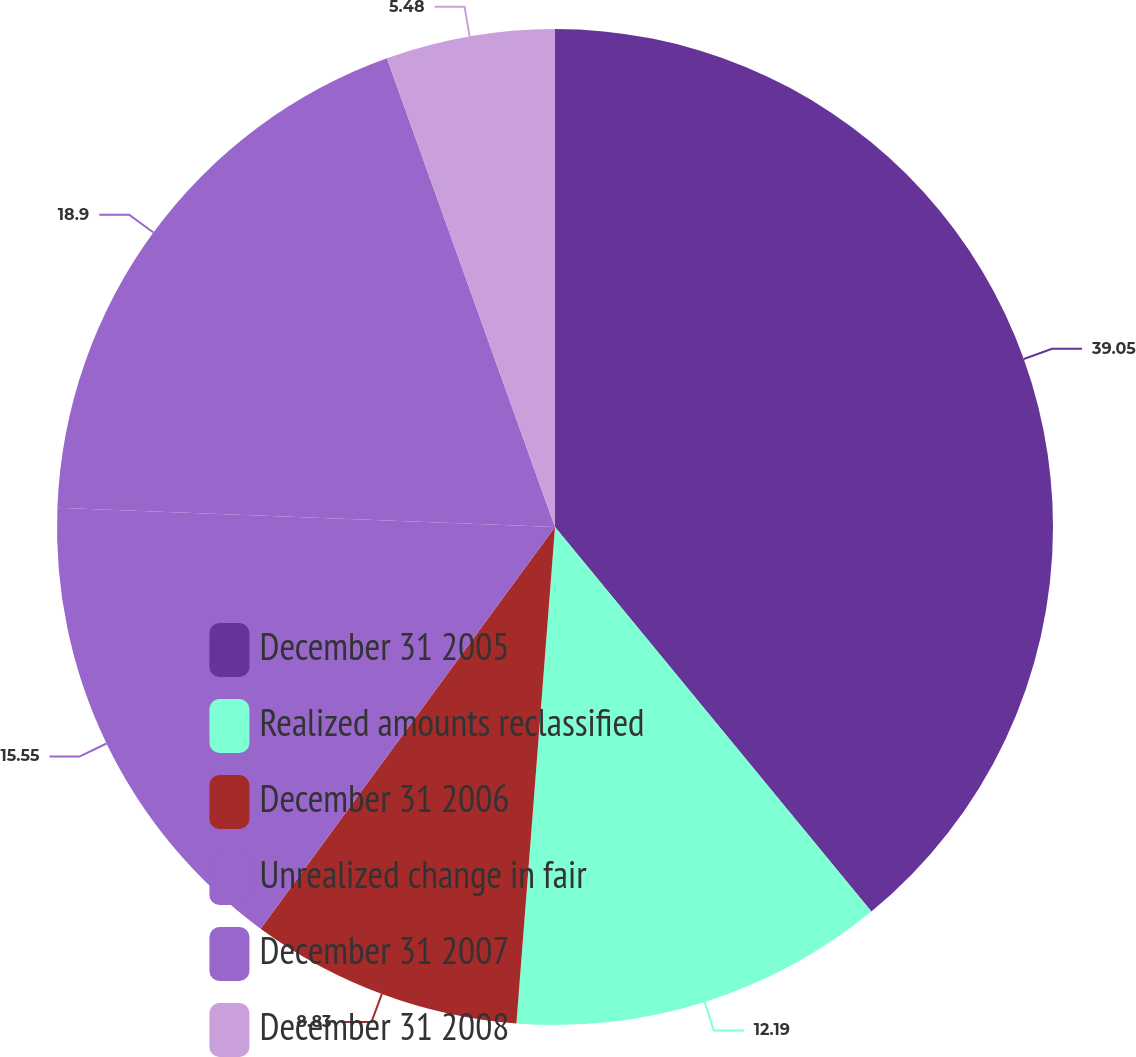Convert chart. <chart><loc_0><loc_0><loc_500><loc_500><pie_chart><fcel>December 31 2005<fcel>Realized amounts reclassified<fcel>December 31 2006<fcel>Unrealized change in fair<fcel>December 31 2007<fcel>December 31 2008<nl><fcel>39.04%<fcel>12.19%<fcel>8.83%<fcel>15.55%<fcel>18.9%<fcel>5.48%<nl></chart> 